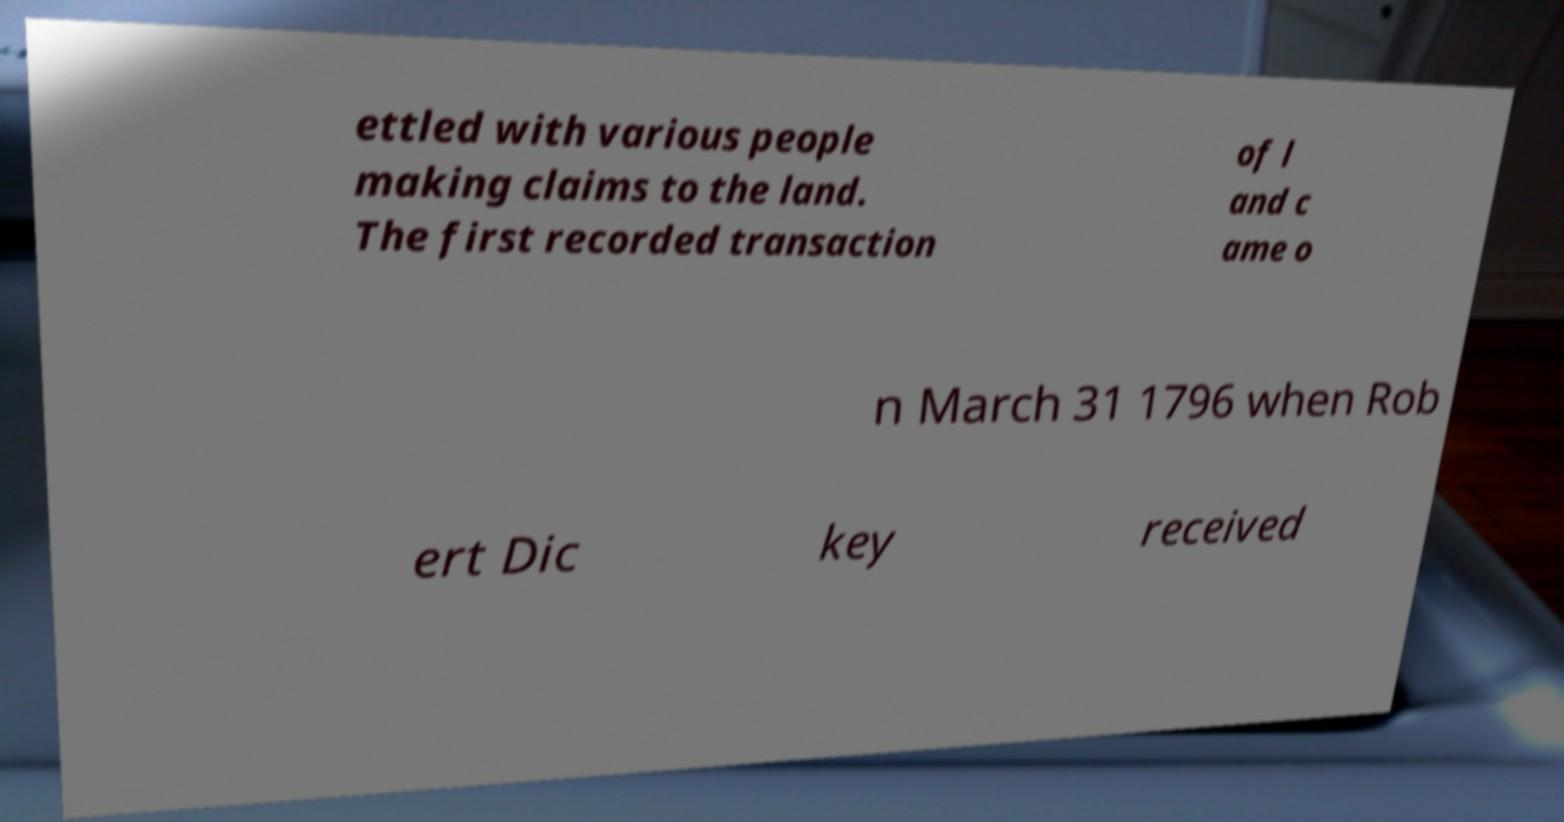Can you accurately transcribe the text from the provided image for me? ettled with various people making claims to the land. The first recorded transaction of l and c ame o n March 31 1796 when Rob ert Dic key received 